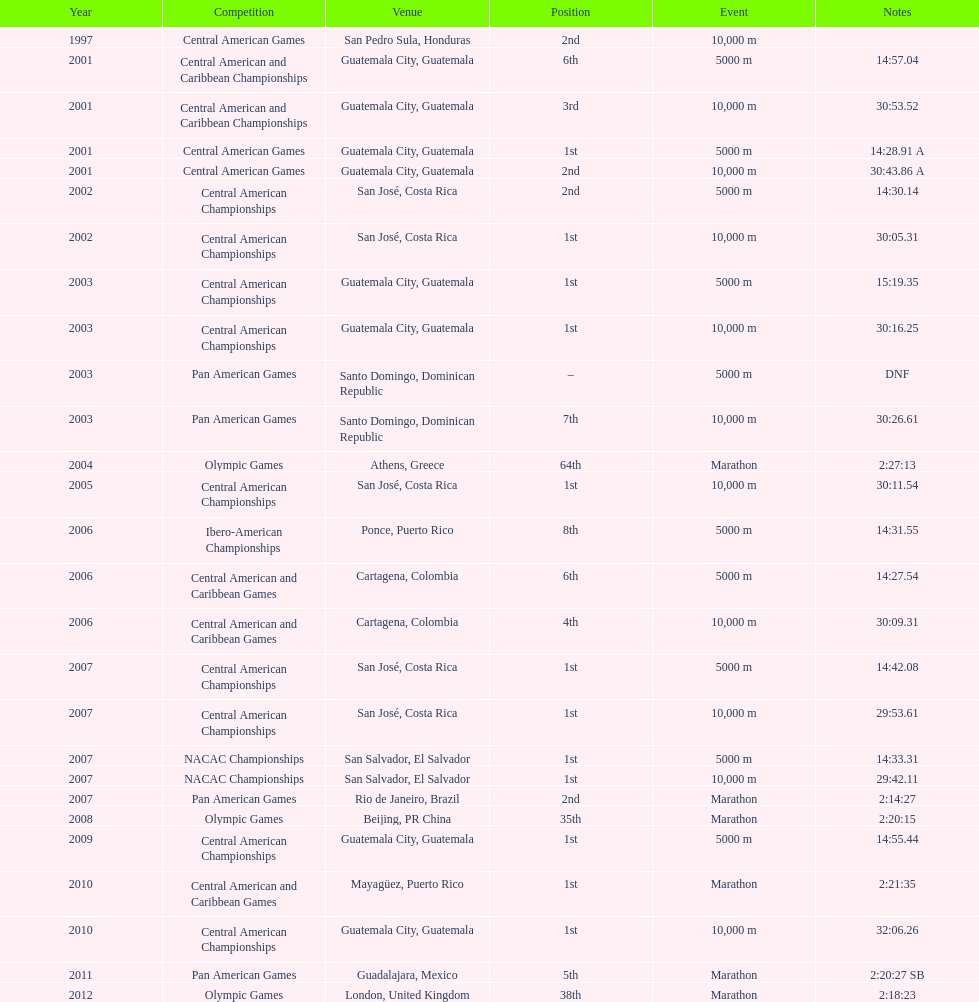Could you help me parse every detail presented in this table? {'header': ['Year', 'Competition', 'Venue', 'Position', 'Event', 'Notes'], 'rows': [['1997', 'Central American Games', 'San Pedro Sula, Honduras', '2nd', '10,000 m', ''], ['2001', 'Central American and Caribbean Championships', 'Guatemala City, Guatemala', '6th', '5000 m', '14:57.04'], ['2001', 'Central American and Caribbean Championships', 'Guatemala City, Guatemala', '3rd', '10,000 m', '30:53.52'], ['2001', 'Central American Games', 'Guatemala City, Guatemala', '1st', '5000 m', '14:28.91 A'], ['2001', 'Central American Games', 'Guatemala City, Guatemala', '2nd', '10,000 m', '30:43.86 A'], ['2002', 'Central American Championships', 'San José, Costa Rica', '2nd', '5000 m', '14:30.14'], ['2002', 'Central American Championships', 'San José, Costa Rica', '1st', '10,000 m', '30:05.31'], ['2003', 'Central American Championships', 'Guatemala City, Guatemala', '1st', '5000 m', '15:19.35'], ['2003', 'Central American Championships', 'Guatemala City, Guatemala', '1st', '10,000 m', '30:16.25'], ['2003', 'Pan American Games', 'Santo Domingo, Dominican Republic', '–', '5000 m', 'DNF'], ['2003', 'Pan American Games', 'Santo Domingo, Dominican Republic', '7th', '10,000 m', '30:26.61'], ['2004', 'Olympic Games', 'Athens, Greece', '64th', 'Marathon', '2:27:13'], ['2005', 'Central American Championships', 'San José, Costa Rica', '1st', '10,000 m', '30:11.54'], ['2006', 'Ibero-American Championships', 'Ponce, Puerto Rico', '8th', '5000 m', '14:31.55'], ['2006', 'Central American and Caribbean Games', 'Cartagena, Colombia', '6th', '5000 m', '14:27.54'], ['2006', 'Central American and Caribbean Games', 'Cartagena, Colombia', '4th', '10,000 m', '30:09.31'], ['2007', 'Central American Championships', 'San José, Costa Rica', '1st', '5000 m', '14:42.08'], ['2007', 'Central American Championships', 'San José, Costa Rica', '1st', '10,000 m', '29:53.61'], ['2007', 'NACAC Championships', 'San Salvador, El Salvador', '1st', '5000 m', '14:33.31'], ['2007', 'NACAC Championships', 'San Salvador, El Salvador', '1st', '10,000 m', '29:42.11'], ['2007', 'Pan American Games', 'Rio de Janeiro, Brazil', '2nd', 'Marathon', '2:14:27'], ['2008', 'Olympic Games', 'Beijing, PR China', '35th', 'Marathon', '2:20:15'], ['2009', 'Central American Championships', 'Guatemala City, Guatemala', '1st', '5000 m', '14:55.44'], ['2010', 'Central American and Caribbean Games', 'Mayagüez, Puerto Rico', '1st', 'Marathon', '2:21:35'], ['2010', 'Central American Championships', 'Guatemala City, Guatemala', '1st', '10,000 m', '32:06.26'], ['2011', 'Pan American Games', 'Guadalajara, Mexico', '5th', 'Marathon', '2:20:27 SB'], ['2012', 'Olympic Games', 'London, United Kingdom', '38th', 'Marathon', '2:18:23']]} Which of each game in 2007 was in the 2nd position? Pan American Games. 